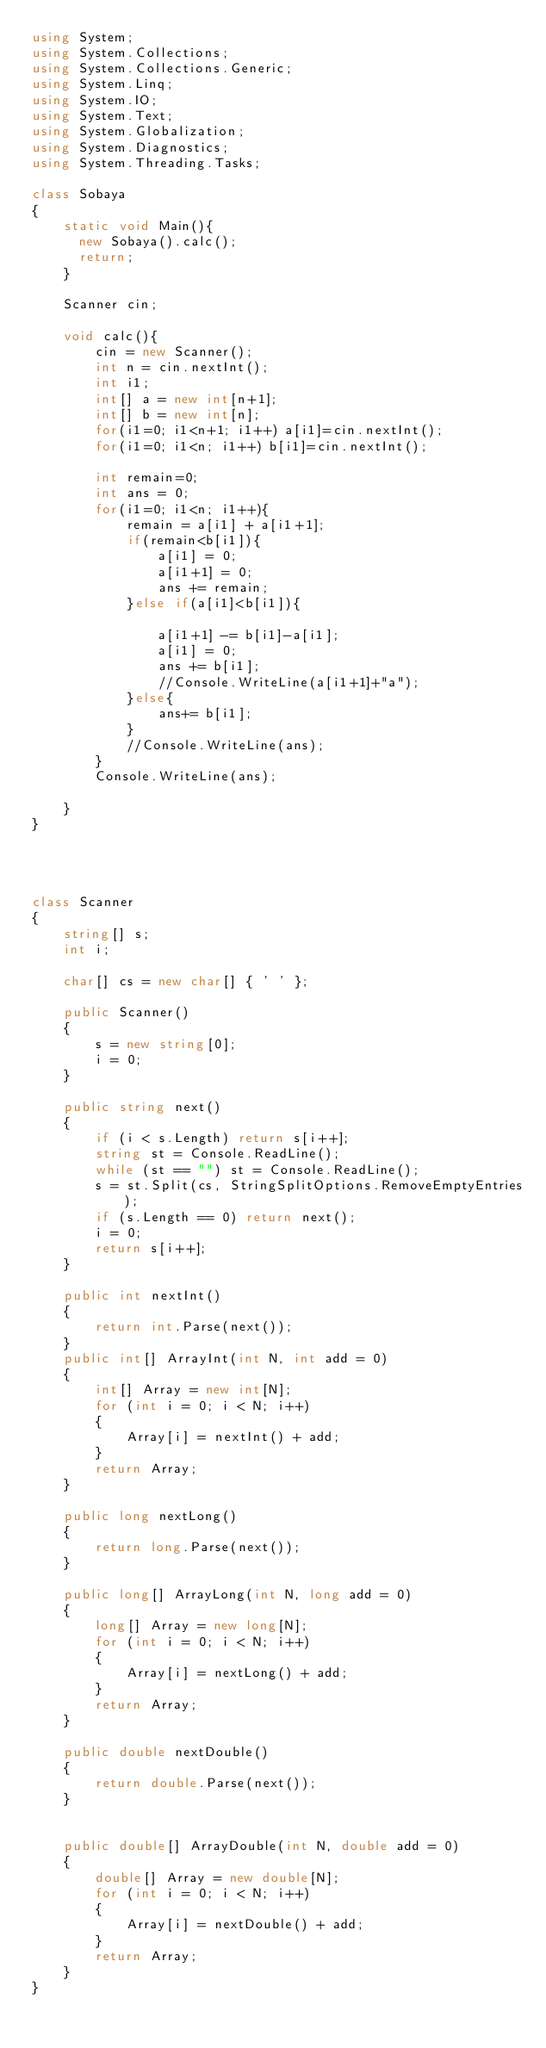Convert code to text. <code><loc_0><loc_0><loc_500><loc_500><_C#_>using System;
using System.Collections;
using System.Collections.Generic;
using System.Linq;
using System.IO;
using System.Text;
using System.Globalization;
using System.Diagnostics;
using System.Threading.Tasks;

class Sobaya
{
    static void Main(){
      new Sobaya().calc();
      return;
    }
      
    Scanner cin;
    
    void calc(){
        cin = new Scanner();
        int n = cin.nextInt();
        int i1;
        int[] a = new int[n+1];
        int[] b = new int[n];
        for(i1=0; i1<n+1; i1++) a[i1]=cin.nextInt();
        for(i1=0; i1<n; i1++) b[i1]=cin.nextInt();
        
        int remain=0;
        int ans = 0;
        for(i1=0; i1<n; i1++){
            remain = a[i1] + a[i1+1];
            if(remain<b[i1]){
                a[i1] = 0;
                a[i1+1] = 0;
                ans += remain;
            }else if(a[i1]<b[i1]){
                
                a[i1+1] -= b[i1]-a[i1];
                a[i1] = 0;
                ans += b[i1];
                //Console.WriteLine(a[i1+1]+"a");
            }else{
                ans+= b[i1];
            }
            //Console.WriteLine(ans);
        }
        Console.WriteLine(ans);

    }
}




class Scanner
{
    string[] s;
    int i;
 
    char[] cs = new char[] { ' ' };
 
    public Scanner()
    {
        s = new string[0];
        i = 0;
    }
 
    public string next()
    {
        if (i < s.Length) return s[i++];
        string st = Console.ReadLine();
        while (st == "") st = Console.ReadLine();
        s = st.Split(cs, StringSplitOptions.RemoveEmptyEntries);
        if (s.Length == 0) return next();
        i = 0;
        return s[i++];
    }
 
    public int nextInt()
    {
        return int.Parse(next());
    }
    public int[] ArrayInt(int N, int add = 0)
    {
        int[] Array = new int[N];
        for (int i = 0; i < N; i++)
        {
            Array[i] = nextInt() + add;
        }
        return Array;
    }
 
    public long nextLong()
    {
        return long.Parse(next());
    }
 
    public long[] ArrayLong(int N, long add = 0)
    {
        long[] Array = new long[N];
        for (int i = 0; i < N; i++)
        {
            Array[i] = nextLong() + add;
        }
        return Array;
    }
 
    public double nextDouble()
    {
        return double.Parse(next());
    }
 
 
    public double[] ArrayDouble(int N, double add = 0)
    {
        double[] Array = new double[N];
        for (int i = 0; i < N; i++)
        {
            Array[i] = nextDouble() + add;
        }
        return Array;
    }
}
</code> 